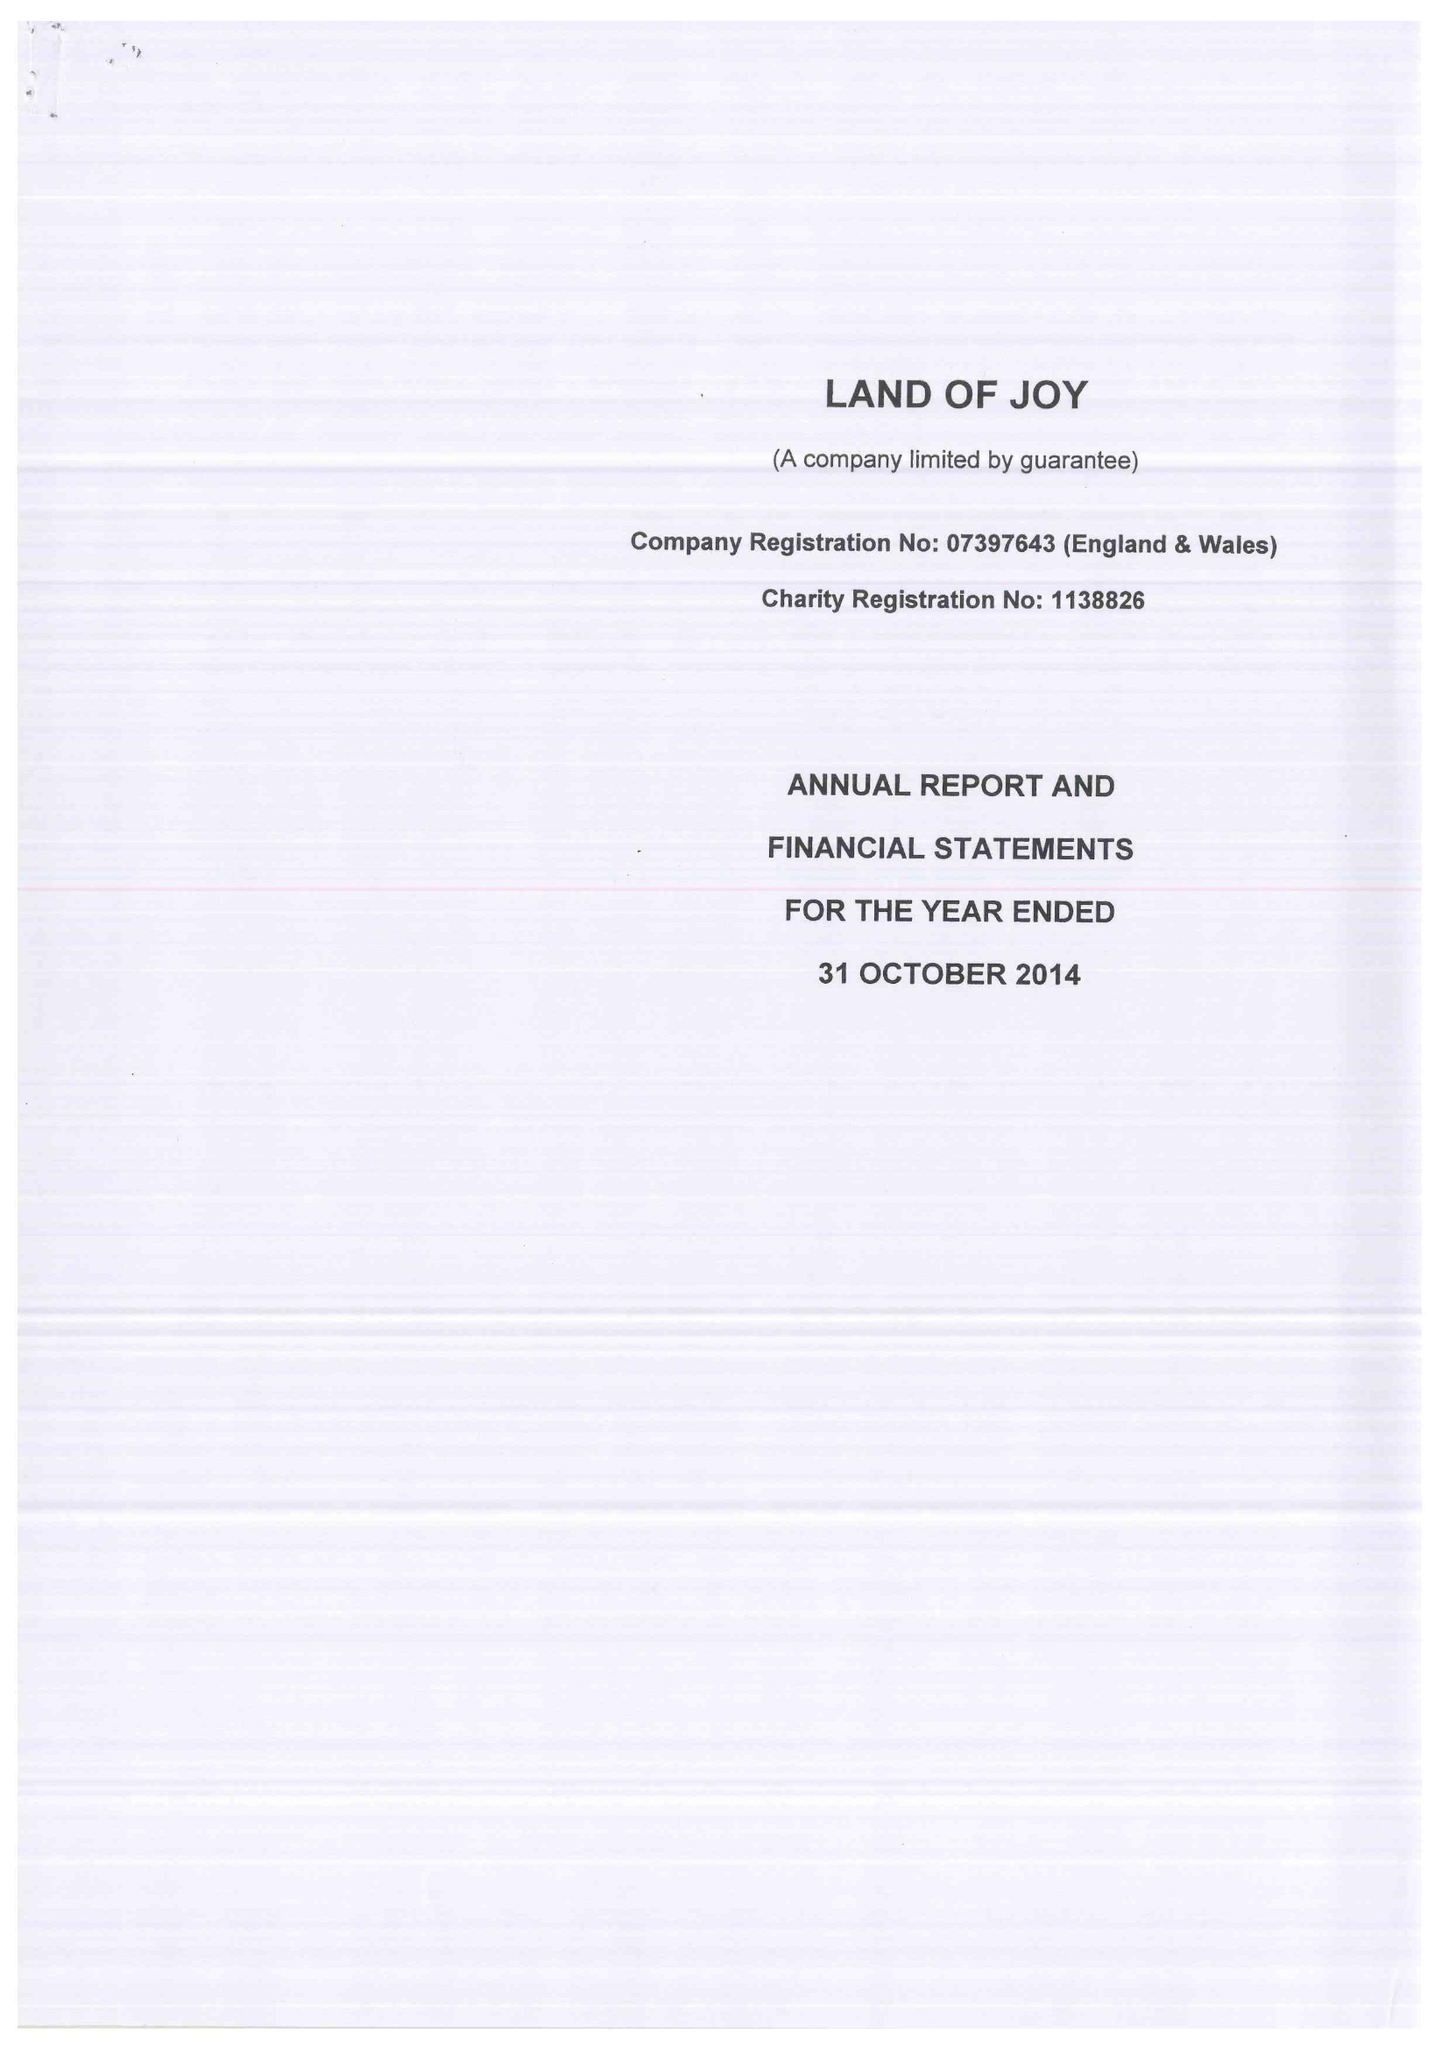What is the value for the report_date?
Answer the question using a single word or phrase. 2014-10-31 